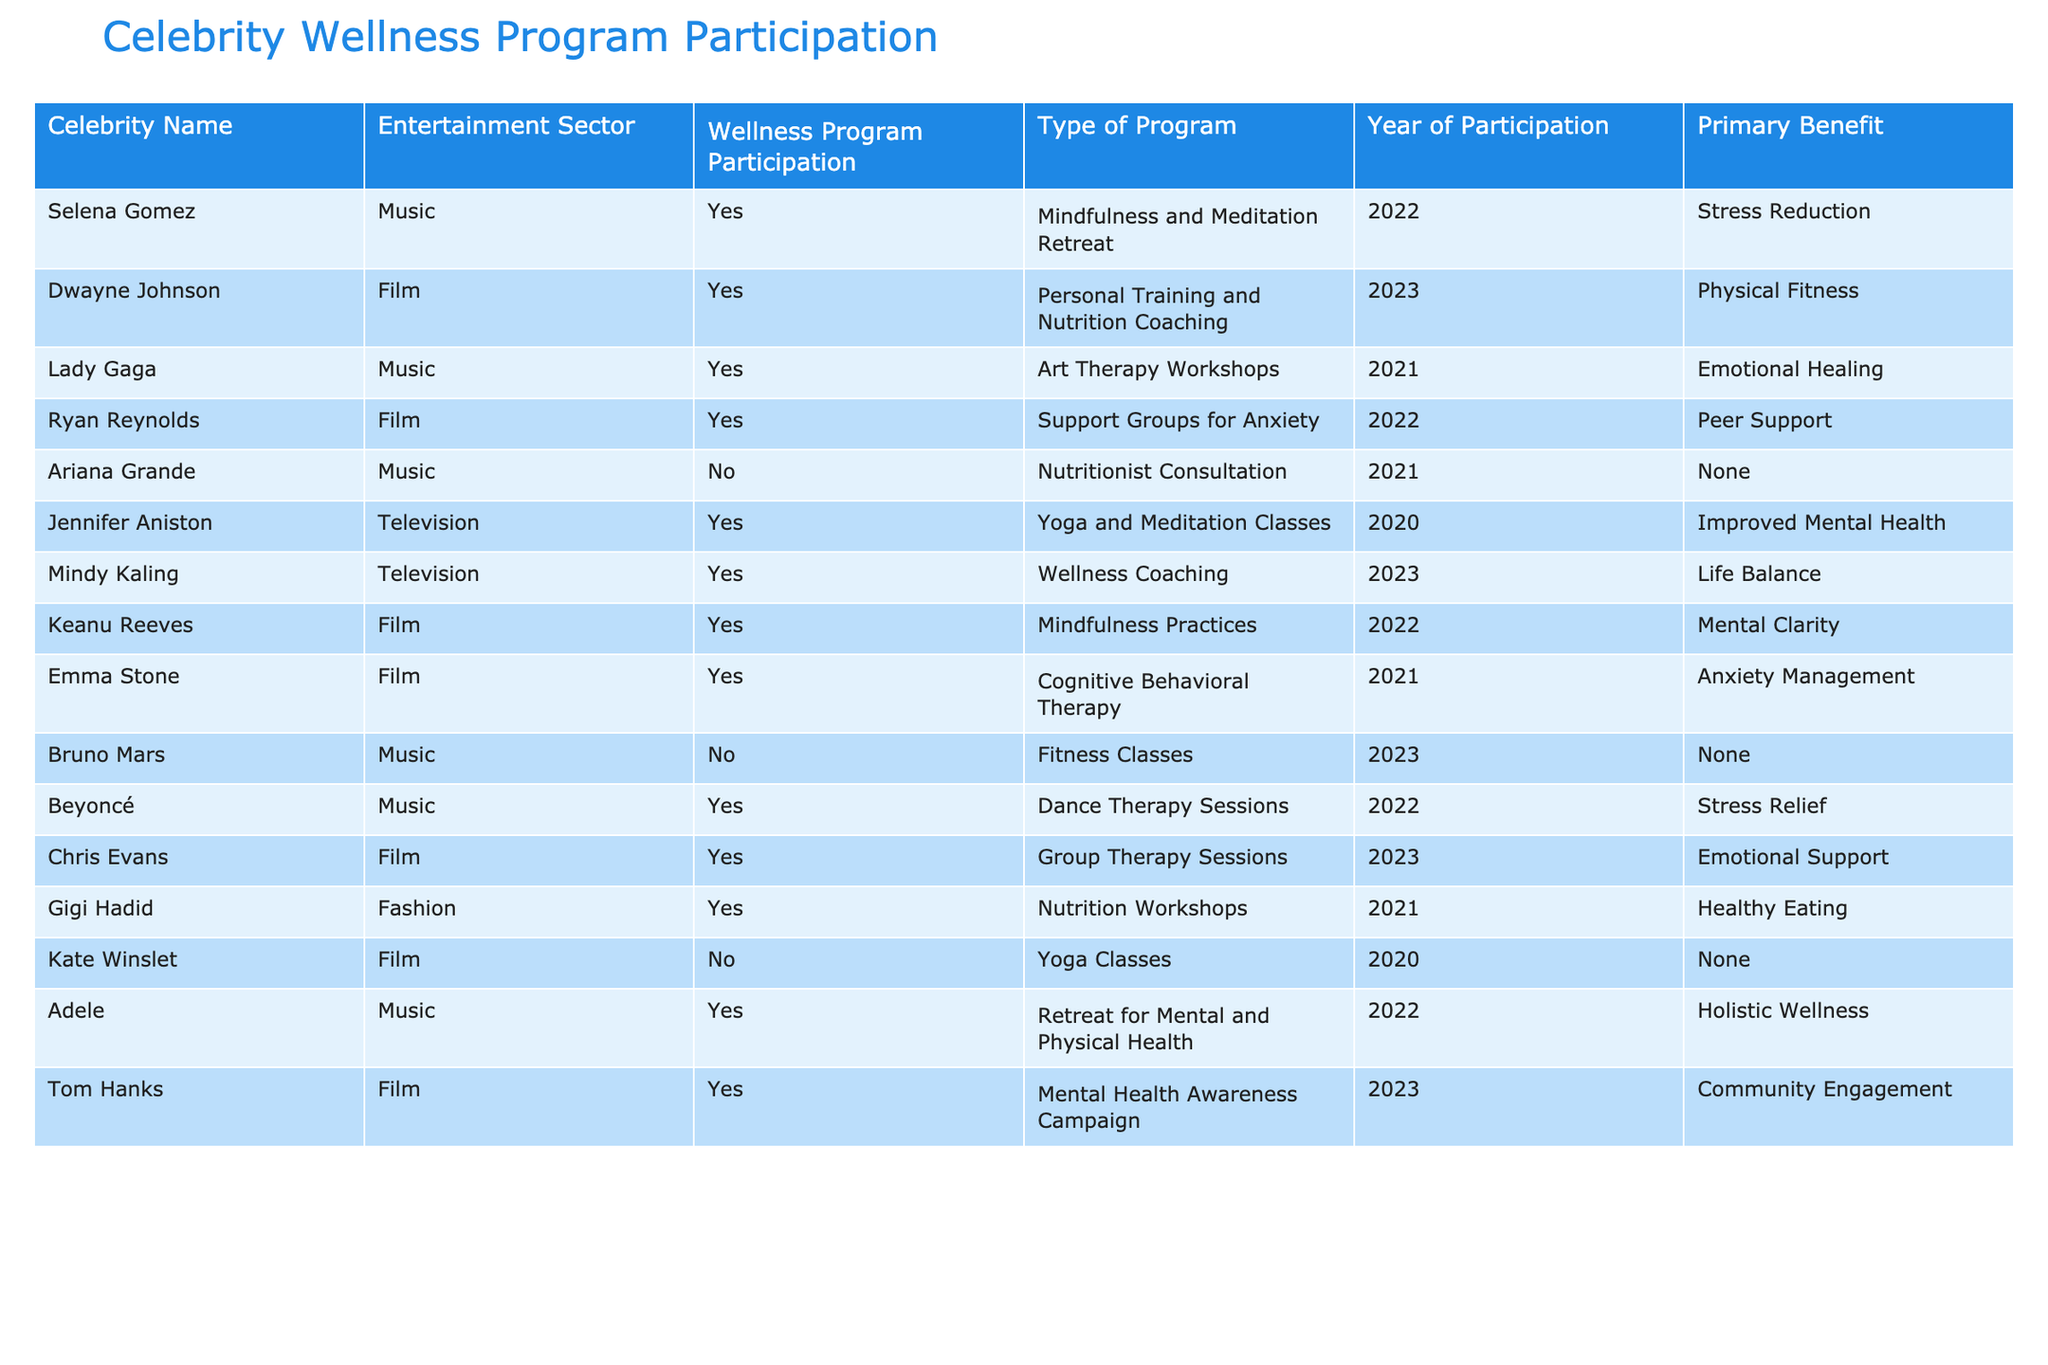What percentage of celebrities in the music sector participated in wellness programs? There are 5 celebrities in the music sector: Selena Gomez, Lady Gaga, Ariana Grande, Beyoncé, and Adele. Out of these, 4 participated in wellness programs (Selena Gomez, Lady Gaga, Beyoncé, and Adele), so the percentage is (4/5) * 100 = 80%.
Answer: 80% Did any celebrities from the fashion sector participate in wellness programs? Gigi Hadid is the only celebrity listed from the fashion sector, and she did participate in a wellness program.
Answer: Yes Which type of wellness program had the most participation among film celebrities? There are 7 film celebrities, and they participated in different types of programs. The options for participation were Personal Training and Nutrition Coaching (1), Support Groups for Anxiety (1), Mindfulness Practices (1), Cognitive Behavioral Therapy (1), Group Therapy Sessions (1), Mental Health Awareness Campaign (1). Each type is unique and has 1 participant, so there is a tie in participation.
Answer: There is a tie What is the primary benefit of the wellness program that Ryan Reynolds participated in? Ryan Reynolds participated in Support Groups for Anxiety in 2022, and the primary benefit listed is Peer Support.
Answer: Peer Support How many celebrities participated in wellness programs in the year 2022? From the data, Selena Gomez, Dwayne Johnson, Beyoncé, Adele, Keanu Reeves, Ryan Reynolds, and Chris Evans participated in wellness programs in 2022. This counts as 6 celebrities.
Answer: 6 What is the difference in participation between music and television sectors? There are 5 music celebrities (selena gomez, lady gaga, ariana grande, beyonce, adele) and 3 television celebrities (jennifer aniston, mindy kaling). Within music, 4 participated, while in television 3 participated, providing a difference of 1 celebrity in favor of music.
Answer: 1 Which celebrity had the primary benefit of "Improved Mental Health"? Jennifer Aniston participated in yoga and meditation classes to achieve improved mental health in 2020.
Answer: Jennifer Aniston What was the only wellness program that Ariana Grande participated in? Ariana Grande did not participate in any wellness programs; she had a nutritionist consultation that didn't qualify as wellness program participation.
Answer: None Which film celebrity participated in the most programs within the data? Every film celebrity listed participated in only one program, but if we count unique programs, each program appears once, keeping all in equal level, therefore, no one celebrity name can be highlighted as having more programs above others.
Answer: None 